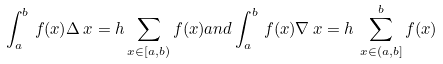<formula> <loc_0><loc_0><loc_500><loc_500>\int _ { a } ^ { b } \, f ( x ) \Delta \, x = h \sum _ { x \in [ a , b ) } f ( x ) a n d \int _ { a } ^ { b } \, f ( x ) \nabla \, x = h \, \sum _ { x \in ( a , b ] } ^ { b } f ( x )</formula> 